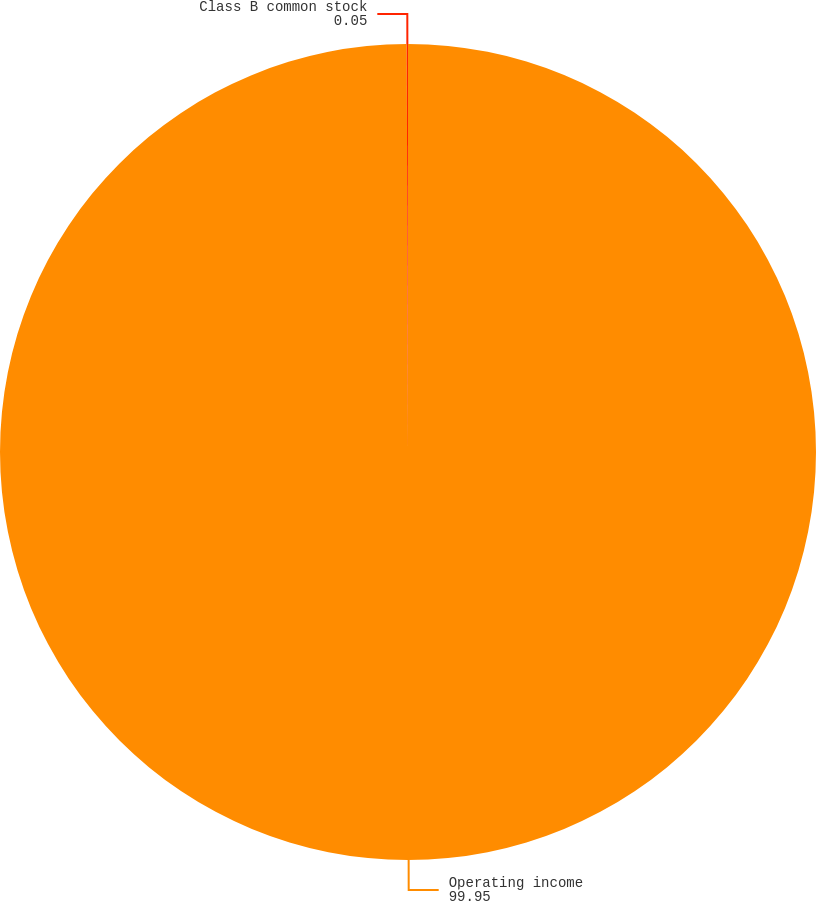Convert chart. <chart><loc_0><loc_0><loc_500><loc_500><pie_chart><fcel>Operating income<fcel>Class B common stock<nl><fcel>99.95%<fcel>0.05%<nl></chart> 